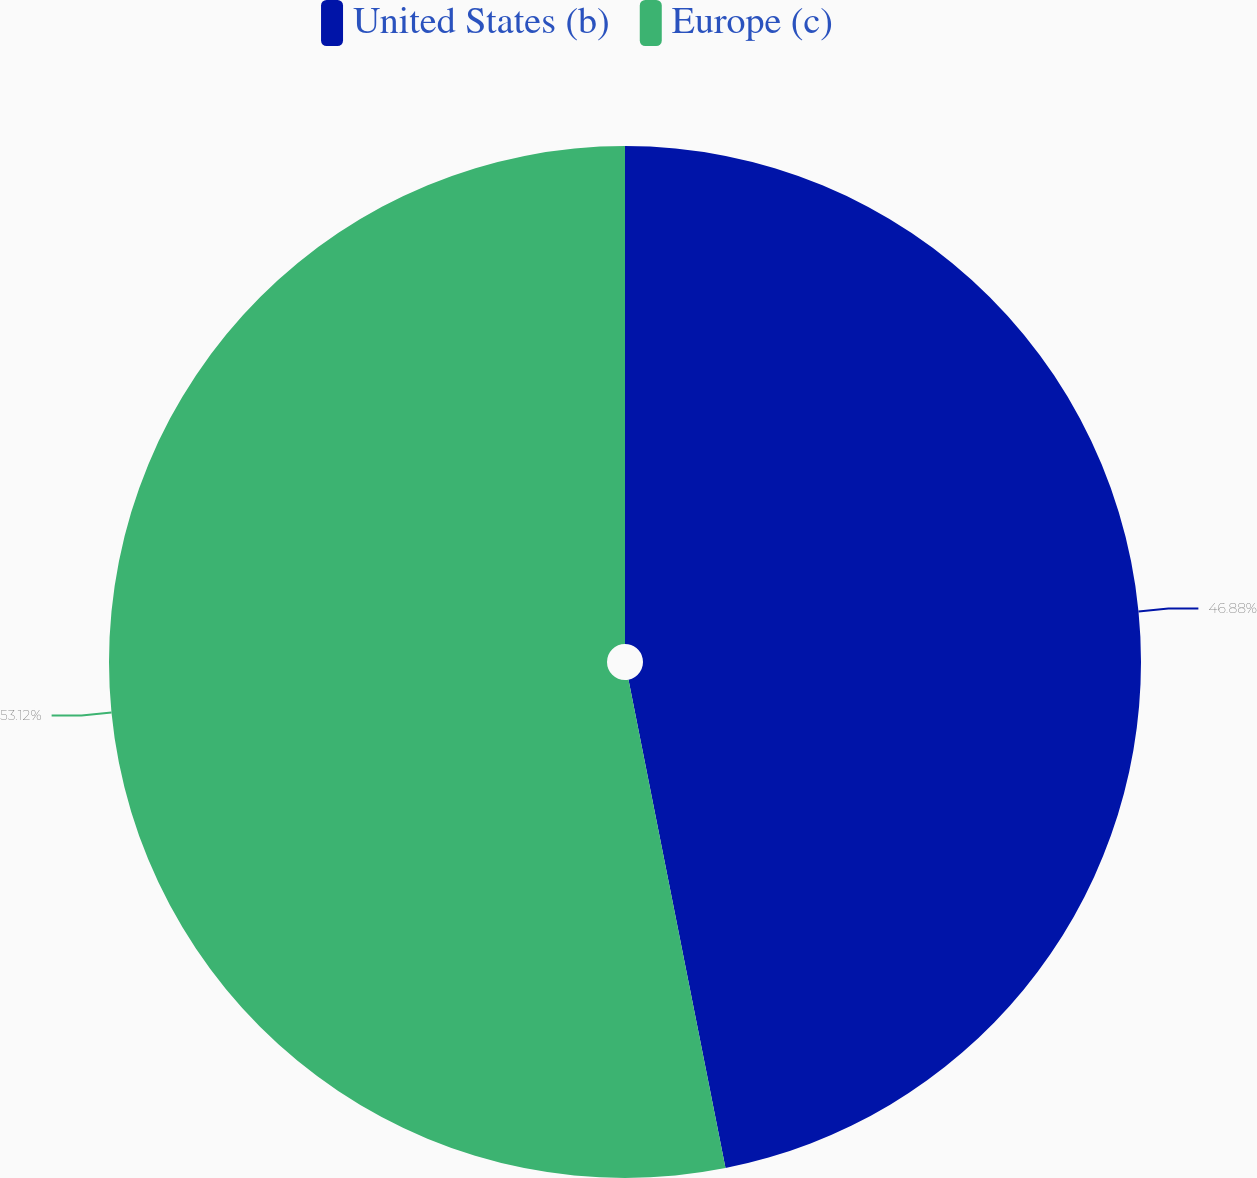<chart> <loc_0><loc_0><loc_500><loc_500><pie_chart><fcel>United States (b)<fcel>Europe (c)<nl><fcel>46.88%<fcel>53.12%<nl></chart> 